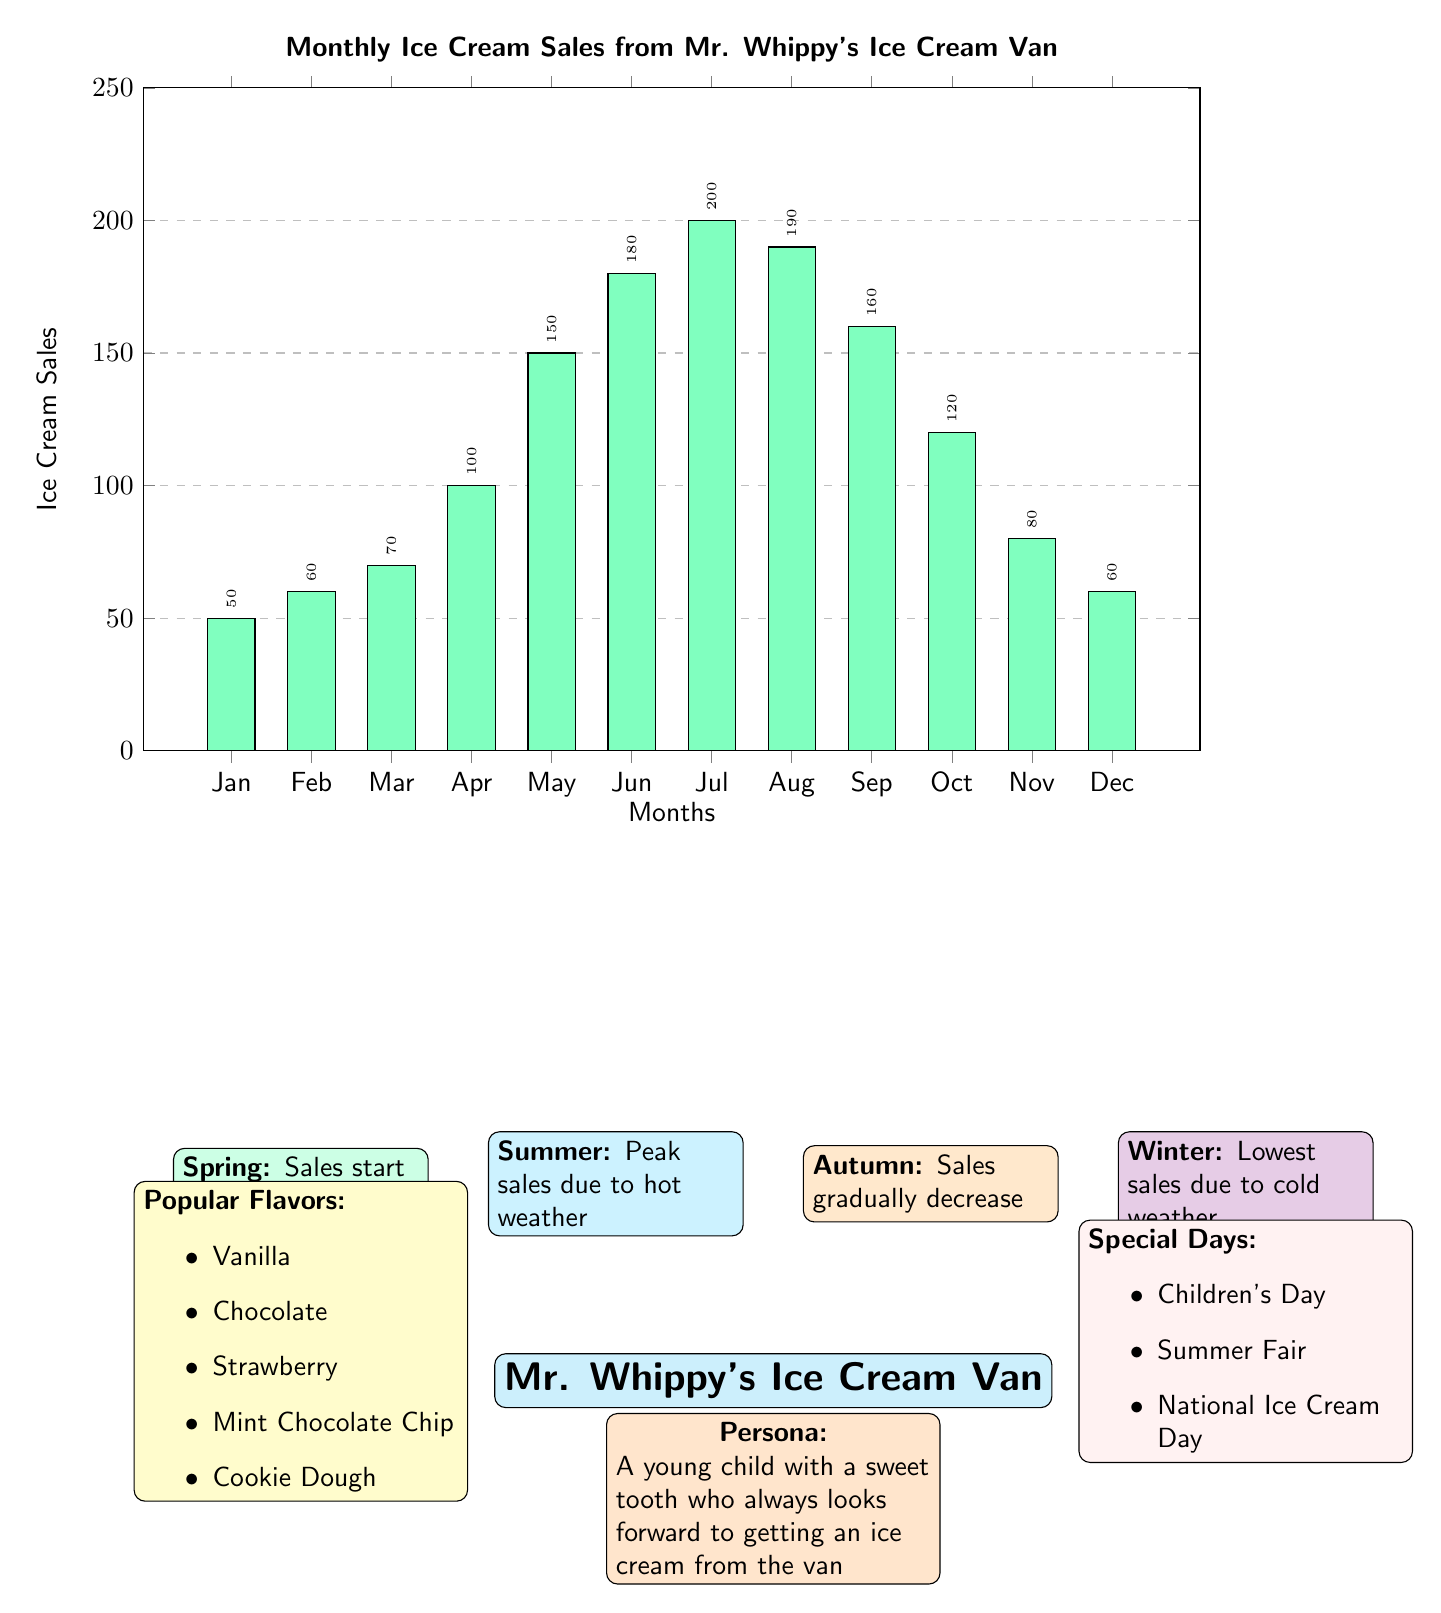What's the highest ice cream sales month? The bar graph indicates that July has the tallest bar, representing the highest sales figure at 200 units.
Answer: July How many units were sold in December? The bar for December shows that 60 units of ice cream were sold, as labeled above the bar.
Answer: 60 What is the sales trend during summer? The diagram notes that in summer (June, July, August), ice cream sales peak, specifically with July being the highest at 200 units.
Answer: Peak sales Which month has the lowest sales? December shows the lowest sales value in the bar graph at 60 units.
Answer: December What are the popular flavors listed? The diagram itemizes five popular flavors: Vanilla, Chocolate, Strawberry, Mint Chocolate Chip, and Cookie Dough.
Answer: Vanilla, Chocolate, Strawberry, Mint Chocolate Chip, Cookie Dough How does spring affect sales? In the diagram, it states that sales start to increase in spring, specifically noting an increase from January to April.
Answer: Sales start to increase What special days could affect ice cream sales? There are three special days mentioned: Children's Day, Summer Fair, and National Ice Cream Day, which could lead to increased sales.
Answer: Children's Day, Summer Fair, National Ice Cream Day How many months had sales over 100 units? By counting the months in the bar graph, we see that April, May, June, July, August, September, and October (7 months) all had sales over 100 units.
Answer: 7 months What seasonal trend is associated with winter? The diagram states that winter has the lowest sales due to cold weather, indicating that ice cream sales decrease significantly during this season.
Answer: Lowest sales 